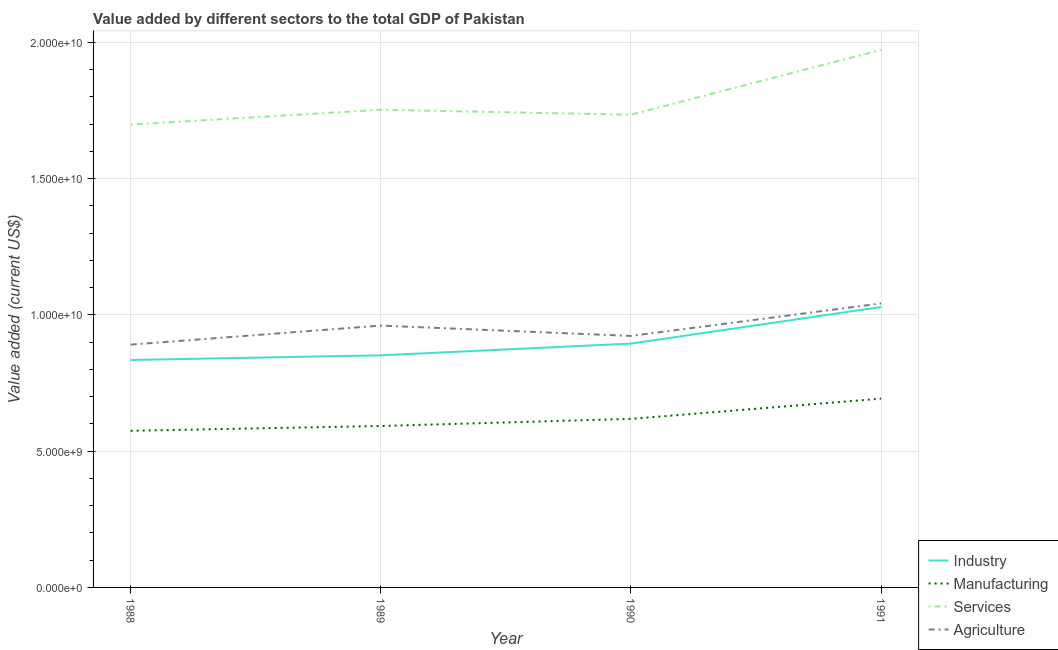Does the line corresponding to value added by services sector intersect with the line corresponding to value added by agricultural sector?
Make the answer very short. No. Is the number of lines equal to the number of legend labels?
Your response must be concise. Yes. What is the value added by industrial sector in 1991?
Make the answer very short. 1.03e+1. Across all years, what is the maximum value added by industrial sector?
Keep it short and to the point. 1.03e+1. Across all years, what is the minimum value added by industrial sector?
Offer a very short reply. 8.35e+09. In which year was the value added by agricultural sector maximum?
Ensure brevity in your answer.  1991. In which year was the value added by services sector minimum?
Ensure brevity in your answer.  1988. What is the total value added by manufacturing sector in the graph?
Your answer should be compact. 2.48e+1. What is the difference between the value added by manufacturing sector in 1990 and that in 1991?
Offer a very short reply. -7.43e+08. What is the difference between the value added by manufacturing sector in 1989 and the value added by industrial sector in 1991?
Provide a short and direct response. -4.37e+09. What is the average value added by agricultural sector per year?
Make the answer very short. 9.54e+09. In the year 1990, what is the difference between the value added by agricultural sector and value added by industrial sector?
Provide a succinct answer. 2.80e+08. In how many years, is the value added by services sector greater than 1000000000 US$?
Provide a short and direct response. 4. What is the ratio of the value added by industrial sector in 1990 to that in 1991?
Your answer should be compact. 0.87. What is the difference between the highest and the second highest value added by manufacturing sector?
Offer a very short reply. 7.43e+08. What is the difference between the highest and the lowest value added by agricultural sector?
Your answer should be very brief. 1.51e+09. In how many years, is the value added by industrial sector greater than the average value added by industrial sector taken over all years?
Offer a terse response. 1. Is it the case that in every year, the sum of the value added by industrial sector and value added by manufacturing sector is greater than the value added by services sector?
Offer a terse response. No. Is the value added by agricultural sector strictly less than the value added by industrial sector over the years?
Provide a succinct answer. No. How many lines are there?
Offer a terse response. 4. What is the difference between two consecutive major ticks on the Y-axis?
Your answer should be very brief. 5.00e+09. Does the graph contain any zero values?
Provide a succinct answer. No. Does the graph contain grids?
Offer a very short reply. Yes. How many legend labels are there?
Offer a very short reply. 4. What is the title of the graph?
Your answer should be very brief. Value added by different sectors to the total GDP of Pakistan. Does "Sweden" appear as one of the legend labels in the graph?
Your answer should be compact. No. What is the label or title of the Y-axis?
Keep it short and to the point. Value added (current US$). What is the Value added (current US$) of Industry in 1988?
Provide a succinct answer. 8.35e+09. What is the Value added (current US$) in Manufacturing in 1988?
Ensure brevity in your answer.  5.75e+09. What is the Value added (current US$) of Services in 1988?
Provide a short and direct response. 1.70e+1. What is the Value added (current US$) in Agriculture in 1988?
Make the answer very short. 8.91e+09. What is the Value added (current US$) of Industry in 1989?
Make the answer very short. 8.52e+09. What is the Value added (current US$) in Manufacturing in 1989?
Offer a very short reply. 5.92e+09. What is the Value added (current US$) in Services in 1989?
Offer a very short reply. 1.75e+1. What is the Value added (current US$) in Agriculture in 1989?
Provide a short and direct response. 9.61e+09. What is the Value added (current US$) in Industry in 1990?
Offer a terse response. 8.95e+09. What is the Value added (current US$) of Manufacturing in 1990?
Provide a succinct answer. 6.18e+09. What is the Value added (current US$) of Services in 1990?
Your answer should be very brief. 1.73e+1. What is the Value added (current US$) in Agriculture in 1990?
Keep it short and to the point. 9.23e+09. What is the Value added (current US$) in Industry in 1991?
Your response must be concise. 1.03e+1. What is the Value added (current US$) in Manufacturing in 1991?
Provide a succinct answer. 6.93e+09. What is the Value added (current US$) of Services in 1991?
Ensure brevity in your answer.  1.97e+1. What is the Value added (current US$) of Agriculture in 1991?
Offer a very short reply. 1.04e+1. Across all years, what is the maximum Value added (current US$) of Industry?
Keep it short and to the point. 1.03e+1. Across all years, what is the maximum Value added (current US$) in Manufacturing?
Offer a terse response. 6.93e+09. Across all years, what is the maximum Value added (current US$) of Services?
Keep it short and to the point. 1.97e+1. Across all years, what is the maximum Value added (current US$) of Agriculture?
Your response must be concise. 1.04e+1. Across all years, what is the minimum Value added (current US$) in Industry?
Offer a terse response. 8.35e+09. Across all years, what is the minimum Value added (current US$) of Manufacturing?
Your answer should be very brief. 5.75e+09. Across all years, what is the minimum Value added (current US$) of Services?
Offer a very short reply. 1.70e+1. Across all years, what is the minimum Value added (current US$) in Agriculture?
Offer a very short reply. 8.91e+09. What is the total Value added (current US$) in Industry in the graph?
Make the answer very short. 3.61e+1. What is the total Value added (current US$) in Manufacturing in the graph?
Offer a very short reply. 2.48e+1. What is the total Value added (current US$) of Services in the graph?
Your response must be concise. 7.16e+1. What is the total Value added (current US$) of Agriculture in the graph?
Make the answer very short. 3.82e+1. What is the difference between the Value added (current US$) of Industry in 1988 and that in 1989?
Give a very brief answer. -1.72e+08. What is the difference between the Value added (current US$) of Manufacturing in 1988 and that in 1989?
Offer a terse response. -1.76e+08. What is the difference between the Value added (current US$) in Services in 1988 and that in 1989?
Offer a very short reply. -5.44e+08. What is the difference between the Value added (current US$) in Agriculture in 1988 and that in 1989?
Give a very brief answer. -6.99e+08. What is the difference between the Value added (current US$) of Industry in 1988 and that in 1990?
Give a very brief answer. -6.02e+08. What is the difference between the Value added (current US$) in Manufacturing in 1988 and that in 1990?
Your answer should be very brief. -4.37e+08. What is the difference between the Value added (current US$) of Services in 1988 and that in 1990?
Give a very brief answer. -3.62e+08. What is the difference between the Value added (current US$) in Agriculture in 1988 and that in 1990?
Your response must be concise. -3.18e+08. What is the difference between the Value added (current US$) in Industry in 1988 and that in 1991?
Give a very brief answer. -1.94e+09. What is the difference between the Value added (current US$) in Manufacturing in 1988 and that in 1991?
Provide a succinct answer. -1.18e+09. What is the difference between the Value added (current US$) of Services in 1988 and that in 1991?
Offer a terse response. -2.74e+09. What is the difference between the Value added (current US$) of Agriculture in 1988 and that in 1991?
Keep it short and to the point. -1.51e+09. What is the difference between the Value added (current US$) in Industry in 1989 and that in 1990?
Provide a succinct answer. -4.30e+08. What is the difference between the Value added (current US$) of Manufacturing in 1989 and that in 1990?
Your answer should be very brief. -2.61e+08. What is the difference between the Value added (current US$) of Services in 1989 and that in 1990?
Provide a short and direct response. 1.82e+08. What is the difference between the Value added (current US$) in Agriculture in 1989 and that in 1990?
Keep it short and to the point. 3.80e+08. What is the difference between the Value added (current US$) of Industry in 1989 and that in 1991?
Provide a succinct answer. -1.77e+09. What is the difference between the Value added (current US$) in Manufacturing in 1989 and that in 1991?
Keep it short and to the point. -1.00e+09. What is the difference between the Value added (current US$) in Services in 1989 and that in 1991?
Offer a terse response. -2.20e+09. What is the difference between the Value added (current US$) in Agriculture in 1989 and that in 1991?
Your answer should be compact. -8.14e+08. What is the difference between the Value added (current US$) of Industry in 1990 and that in 1991?
Keep it short and to the point. -1.34e+09. What is the difference between the Value added (current US$) of Manufacturing in 1990 and that in 1991?
Your response must be concise. -7.43e+08. What is the difference between the Value added (current US$) in Services in 1990 and that in 1991?
Provide a succinct answer. -2.38e+09. What is the difference between the Value added (current US$) of Agriculture in 1990 and that in 1991?
Your response must be concise. -1.19e+09. What is the difference between the Value added (current US$) in Industry in 1988 and the Value added (current US$) in Manufacturing in 1989?
Offer a very short reply. 2.42e+09. What is the difference between the Value added (current US$) in Industry in 1988 and the Value added (current US$) in Services in 1989?
Ensure brevity in your answer.  -9.18e+09. What is the difference between the Value added (current US$) of Industry in 1988 and the Value added (current US$) of Agriculture in 1989?
Provide a short and direct response. -1.26e+09. What is the difference between the Value added (current US$) of Manufacturing in 1988 and the Value added (current US$) of Services in 1989?
Offer a terse response. -1.18e+1. What is the difference between the Value added (current US$) in Manufacturing in 1988 and the Value added (current US$) in Agriculture in 1989?
Offer a very short reply. -3.86e+09. What is the difference between the Value added (current US$) in Services in 1988 and the Value added (current US$) in Agriculture in 1989?
Your answer should be very brief. 7.37e+09. What is the difference between the Value added (current US$) in Industry in 1988 and the Value added (current US$) in Manufacturing in 1990?
Your answer should be very brief. 2.16e+09. What is the difference between the Value added (current US$) in Industry in 1988 and the Value added (current US$) in Services in 1990?
Ensure brevity in your answer.  -9.00e+09. What is the difference between the Value added (current US$) of Industry in 1988 and the Value added (current US$) of Agriculture in 1990?
Keep it short and to the point. -8.82e+08. What is the difference between the Value added (current US$) in Manufacturing in 1988 and the Value added (current US$) in Services in 1990?
Offer a very short reply. -1.16e+1. What is the difference between the Value added (current US$) of Manufacturing in 1988 and the Value added (current US$) of Agriculture in 1990?
Your answer should be compact. -3.48e+09. What is the difference between the Value added (current US$) of Services in 1988 and the Value added (current US$) of Agriculture in 1990?
Offer a very short reply. 7.76e+09. What is the difference between the Value added (current US$) in Industry in 1988 and the Value added (current US$) in Manufacturing in 1991?
Provide a succinct answer. 1.42e+09. What is the difference between the Value added (current US$) of Industry in 1988 and the Value added (current US$) of Services in 1991?
Make the answer very short. -1.14e+1. What is the difference between the Value added (current US$) in Industry in 1988 and the Value added (current US$) in Agriculture in 1991?
Your response must be concise. -2.08e+09. What is the difference between the Value added (current US$) in Manufacturing in 1988 and the Value added (current US$) in Services in 1991?
Offer a terse response. -1.40e+1. What is the difference between the Value added (current US$) of Manufacturing in 1988 and the Value added (current US$) of Agriculture in 1991?
Provide a succinct answer. -4.67e+09. What is the difference between the Value added (current US$) of Services in 1988 and the Value added (current US$) of Agriculture in 1991?
Offer a terse response. 6.56e+09. What is the difference between the Value added (current US$) in Industry in 1989 and the Value added (current US$) in Manufacturing in 1990?
Your answer should be very brief. 2.33e+09. What is the difference between the Value added (current US$) of Industry in 1989 and the Value added (current US$) of Services in 1990?
Offer a terse response. -8.83e+09. What is the difference between the Value added (current US$) in Industry in 1989 and the Value added (current US$) in Agriculture in 1990?
Keep it short and to the point. -7.10e+08. What is the difference between the Value added (current US$) of Manufacturing in 1989 and the Value added (current US$) of Services in 1990?
Provide a succinct answer. -1.14e+1. What is the difference between the Value added (current US$) in Manufacturing in 1989 and the Value added (current US$) in Agriculture in 1990?
Keep it short and to the point. -3.30e+09. What is the difference between the Value added (current US$) of Services in 1989 and the Value added (current US$) of Agriculture in 1990?
Provide a short and direct response. 8.30e+09. What is the difference between the Value added (current US$) in Industry in 1989 and the Value added (current US$) in Manufacturing in 1991?
Provide a succinct answer. 1.59e+09. What is the difference between the Value added (current US$) of Industry in 1989 and the Value added (current US$) of Services in 1991?
Offer a terse response. -1.12e+1. What is the difference between the Value added (current US$) in Industry in 1989 and the Value added (current US$) in Agriculture in 1991?
Your response must be concise. -1.90e+09. What is the difference between the Value added (current US$) in Manufacturing in 1989 and the Value added (current US$) in Services in 1991?
Give a very brief answer. -1.38e+1. What is the difference between the Value added (current US$) of Manufacturing in 1989 and the Value added (current US$) of Agriculture in 1991?
Give a very brief answer. -4.50e+09. What is the difference between the Value added (current US$) in Services in 1989 and the Value added (current US$) in Agriculture in 1991?
Keep it short and to the point. 7.10e+09. What is the difference between the Value added (current US$) of Industry in 1990 and the Value added (current US$) of Manufacturing in 1991?
Provide a short and direct response. 2.02e+09. What is the difference between the Value added (current US$) in Industry in 1990 and the Value added (current US$) in Services in 1991?
Your answer should be compact. -1.08e+1. What is the difference between the Value added (current US$) of Industry in 1990 and the Value added (current US$) of Agriculture in 1991?
Ensure brevity in your answer.  -1.48e+09. What is the difference between the Value added (current US$) of Manufacturing in 1990 and the Value added (current US$) of Services in 1991?
Your answer should be very brief. -1.35e+1. What is the difference between the Value added (current US$) in Manufacturing in 1990 and the Value added (current US$) in Agriculture in 1991?
Make the answer very short. -4.24e+09. What is the difference between the Value added (current US$) of Services in 1990 and the Value added (current US$) of Agriculture in 1991?
Your answer should be very brief. 6.92e+09. What is the average Value added (current US$) of Industry per year?
Give a very brief answer. 9.02e+09. What is the average Value added (current US$) of Manufacturing per year?
Provide a short and direct response. 6.20e+09. What is the average Value added (current US$) in Services per year?
Your answer should be compact. 1.79e+1. What is the average Value added (current US$) of Agriculture per year?
Offer a terse response. 9.54e+09. In the year 1988, what is the difference between the Value added (current US$) in Industry and Value added (current US$) in Manufacturing?
Offer a very short reply. 2.60e+09. In the year 1988, what is the difference between the Value added (current US$) in Industry and Value added (current US$) in Services?
Give a very brief answer. -8.64e+09. In the year 1988, what is the difference between the Value added (current US$) in Industry and Value added (current US$) in Agriculture?
Ensure brevity in your answer.  -5.64e+08. In the year 1988, what is the difference between the Value added (current US$) of Manufacturing and Value added (current US$) of Services?
Your answer should be very brief. -1.12e+1. In the year 1988, what is the difference between the Value added (current US$) in Manufacturing and Value added (current US$) in Agriculture?
Provide a succinct answer. -3.16e+09. In the year 1988, what is the difference between the Value added (current US$) of Services and Value added (current US$) of Agriculture?
Provide a succinct answer. 8.07e+09. In the year 1989, what is the difference between the Value added (current US$) of Industry and Value added (current US$) of Manufacturing?
Your answer should be very brief. 2.59e+09. In the year 1989, what is the difference between the Value added (current US$) in Industry and Value added (current US$) in Services?
Provide a succinct answer. -9.01e+09. In the year 1989, what is the difference between the Value added (current US$) in Industry and Value added (current US$) in Agriculture?
Provide a short and direct response. -1.09e+09. In the year 1989, what is the difference between the Value added (current US$) in Manufacturing and Value added (current US$) in Services?
Make the answer very short. -1.16e+1. In the year 1989, what is the difference between the Value added (current US$) in Manufacturing and Value added (current US$) in Agriculture?
Your response must be concise. -3.68e+09. In the year 1989, what is the difference between the Value added (current US$) in Services and Value added (current US$) in Agriculture?
Your answer should be compact. 7.92e+09. In the year 1990, what is the difference between the Value added (current US$) in Industry and Value added (current US$) in Manufacturing?
Your response must be concise. 2.76e+09. In the year 1990, what is the difference between the Value added (current US$) of Industry and Value added (current US$) of Services?
Your answer should be compact. -8.40e+09. In the year 1990, what is the difference between the Value added (current US$) of Industry and Value added (current US$) of Agriculture?
Provide a succinct answer. -2.80e+08. In the year 1990, what is the difference between the Value added (current US$) in Manufacturing and Value added (current US$) in Services?
Make the answer very short. -1.12e+1. In the year 1990, what is the difference between the Value added (current US$) in Manufacturing and Value added (current US$) in Agriculture?
Ensure brevity in your answer.  -3.04e+09. In the year 1990, what is the difference between the Value added (current US$) in Services and Value added (current US$) in Agriculture?
Your answer should be very brief. 8.12e+09. In the year 1991, what is the difference between the Value added (current US$) of Industry and Value added (current US$) of Manufacturing?
Ensure brevity in your answer.  3.36e+09. In the year 1991, what is the difference between the Value added (current US$) in Industry and Value added (current US$) in Services?
Your response must be concise. -9.44e+09. In the year 1991, what is the difference between the Value added (current US$) of Industry and Value added (current US$) of Agriculture?
Keep it short and to the point. -1.33e+08. In the year 1991, what is the difference between the Value added (current US$) in Manufacturing and Value added (current US$) in Services?
Provide a succinct answer. -1.28e+1. In the year 1991, what is the difference between the Value added (current US$) of Manufacturing and Value added (current US$) of Agriculture?
Provide a short and direct response. -3.49e+09. In the year 1991, what is the difference between the Value added (current US$) in Services and Value added (current US$) in Agriculture?
Your response must be concise. 9.30e+09. What is the ratio of the Value added (current US$) in Industry in 1988 to that in 1989?
Your answer should be very brief. 0.98. What is the ratio of the Value added (current US$) in Manufacturing in 1988 to that in 1989?
Your answer should be very brief. 0.97. What is the ratio of the Value added (current US$) in Agriculture in 1988 to that in 1989?
Your answer should be compact. 0.93. What is the ratio of the Value added (current US$) in Industry in 1988 to that in 1990?
Keep it short and to the point. 0.93. What is the ratio of the Value added (current US$) of Manufacturing in 1988 to that in 1990?
Keep it short and to the point. 0.93. What is the ratio of the Value added (current US$) of Services in 1988 to that in 1990?
Offer a terse response. 0.98. What is the ratio of the Value added (current US$) in Agriculture in 1988 to that in 1990?
Offer a terse response. 0.97. What is the ratio of the Value added (current US$) in Industry in 1988 to that in 1991?
Offer a very short reply. 0.81. What is the ratio of the Value added (current US$) in Manufacturing in 1988 to that in 1991?
Offer a terse response. 0.83. What is the ratio of the Value added (current US$) of Services in 1988 to that in 1991?
Offer a terse response. 0.86. What is the ratio of the Value added (current US$) in Agriculture in 1988 to that in 1991?
Your response must be concise. 0.85. What is the ratio of the Value added (current US$) in Industry in 1989 to that in 1990?
Your answer should be very brief. 0.95. What is the ratio of the Value added (current US$) in Manufacturing in 1989 to that in 1990?
Your answer should be very brief. 0.96. What is the ratio of the Value added (current US$) of Services in 1989 to that in 1990?
Offer a terse response. 1.01. What is the ratio of the Value added (current US$) in Agriculture in 1989 to that in 1990?
Your answer should be very brief. 1.04. What is the ratio of the Value added (current US$) of Industry in 1989 to that in 1991?
Offer a terse response. 0.83. What is the ratio of the Value added (current US$) in Manufacturing in 1989 to that in 1991?
Make the answer very short. 0.85. What is the ratio of the Value added (current US$) of Services in 1989 to that in 1991?
Keep it short and to the point. 0.89. What is the ratio of the Value added (current US$) of Agriculture in 1989 to that in 1991?
Provide a short and direct response. 0.92. What is the ratio of the Value added (current US$) of Industry in 1990 to that in 1991?
Offer a terse response. 0.87. What is the ratio of the Value added (current US$) of Manufacturing in 1990 to that in 1991?
Your answer should be compact. 0.89. What is the ratio of the Value added (current US$) of Services in 1990 to that in 1991?
Your response must be concise. 0.88. What is the ratio of the Value added (current US$) in Agriculture in 1990 to that in 1991?
Provide a short and direct response. 0.89. What is the difference between the highest and the second highest Value added (current US$) in Industry?
Keep it short and to the point. 1.34e+09. What is the difference between the highest and the second highest Value added (current US$) in Manufacturing?
Your answer should be very brief. 7.43e+08. What is the difference between the highest and the second highest Value added (current US$) in Services?
Offer a very short reply. 2.20e+09. What is the difference between the highest and the second highest Value added (current US$) of Agriculture?
Provide a short and direct response. 8.14e+08. What is the difference between the highest and the lowest Value added (current US$) of Industry?
Keep it short and to the point. 1.94e+09. What is the difference between the highest and the lowest Value added (current US$) in Manufacturing?
Your answer should be compact. 1.18e+09. What is the difference between the highest and the lowest Value added (current US$) of Services?
Provide a succinct answer. 2.74e+09. What is the difference between the highest and the lowest Value added (current US$) of Agriculture?
Make the answer very short. 1.51e+09. 